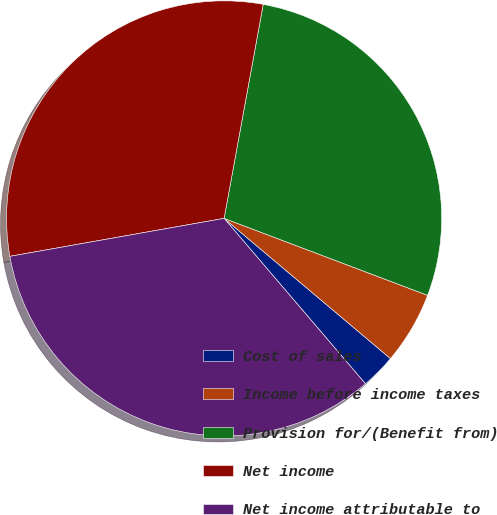Convert chart. <chart><loc_0><loc_0><loc_500><loc_500><pie_chart><fcel>Cost of sales<fcel>Income before income taxes<fcel>Provision for/(Benefit from)<fcel>Net income<fcel>Net income attributable to<nl><fcel>2.6%<fcel>5.39%<fcel>27.88%<fcel>30.67%<fcel>33.46%<nl></chart> 